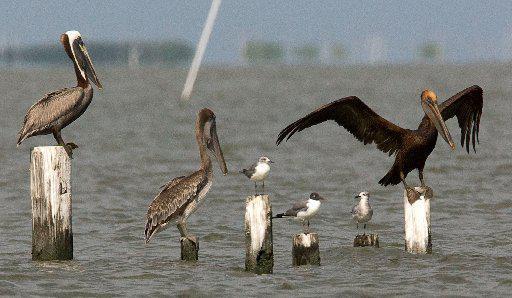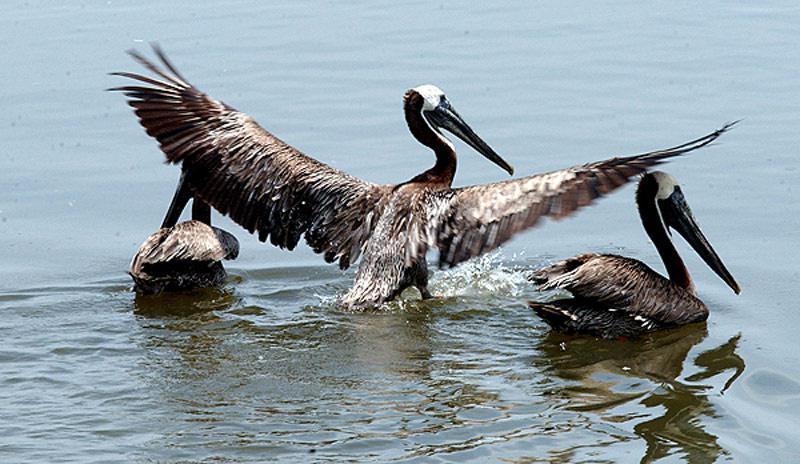The first image is the image on the left, the second image is the image on the right. Examine the images to the left and right. Is the description "Three pelicans perch on wood posts in the water in the left image." accurate? Answer yes or no. Yes. 